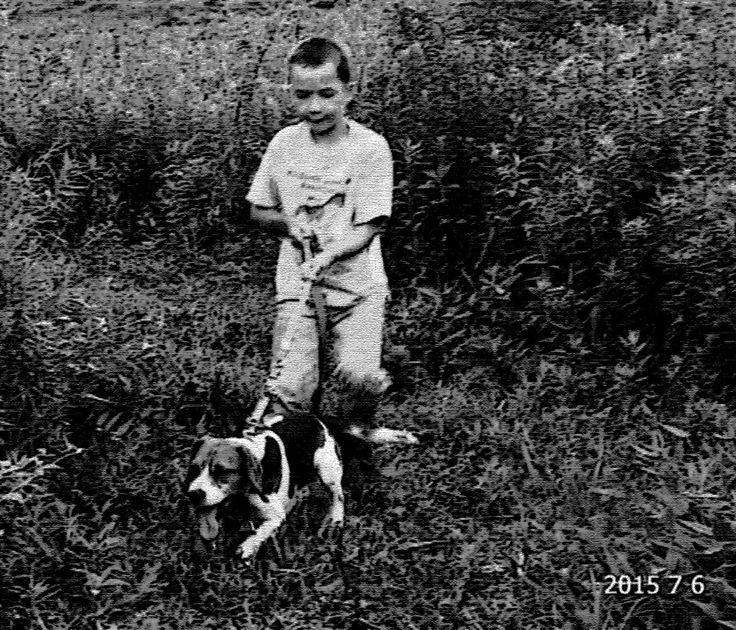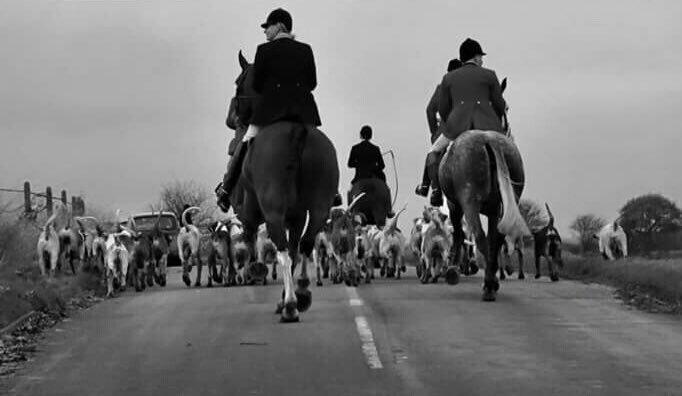The first image is the image on the left, the second image is the image on the right. For the images displayed, is the sentence "In one image, fox hunters are on horses with a pack of hounds." factually correct? Answer yes or no. Yes. 